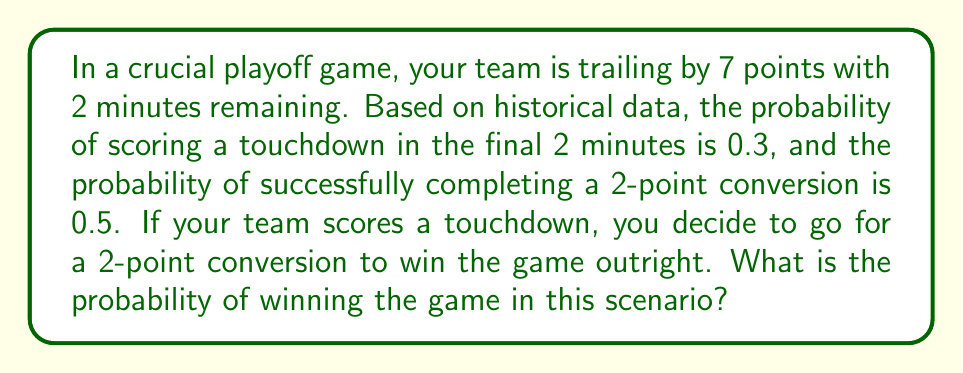Provide a solution to this math problem. Let's approach this step-by-step:

1) First, we need to identify the events that need to occur for your team to win:
   - Score a touchdown (TD)
   - Successfully complete the 2-point conversion

2) We're given the following probabilities:
   - P(TD) = 0.3 (probability of scoring a touchdown)
   - P(2PC|TD) = 0.5 (probability of successful 2-point conversion, given that a touchdown is scored)

3) To win the game, both events must occur. This is a case of dependent events, so we multiply the probabilities:

   $$P(\text{Win}) = P(TD) \times P(2PC|TD)$$

4) Substituting the given values:

   $$P(\text{Win}) = 0.3 \times 0.5$$

5) Calculating:

   $$P(\text{Win}) = 0.15$$

6) Therefore, the probability of winning the game in this scenario is 0.15 or 15%.

This calculation demonstrates how your split-second decision to go for a 2-point conversion affects the overall probability of winning, given the time constraint and score differential.
Answer: 0.15 